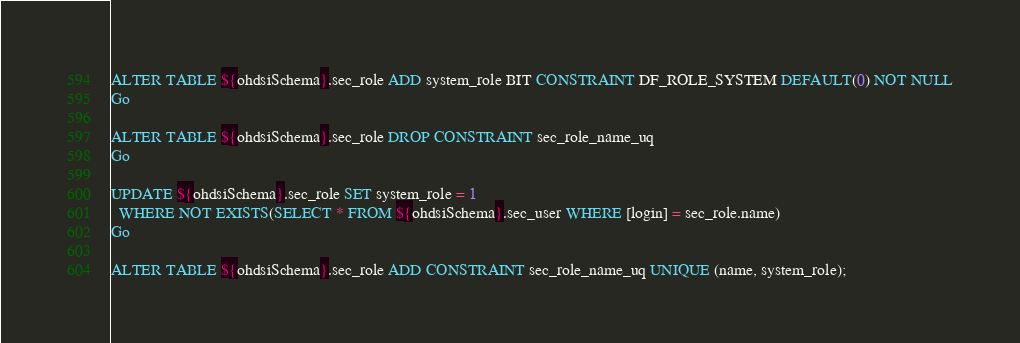Convert code to text. <code><loc_0><loc_0><loc_500><loc_500><_SQL_>ALTER TABLE ${ohdsiSchema}.sec_role ADD system_role BIT CONSTRAINT DF_ROLE_SYSTEM DEFAULT(0) NOT NULL
Go

ALTER TABLE ${ohdsiSchema}.sec_role DROP CONSTRAINT sec_role_name_uq
Go

UPDATE ${ohdsiSchema}.sec_role SET system_role = 1
  WHERE NOT EXISTS(SELECT * FROM ${ohdsiSchema}.sec_user WHERE [login] = sec_role.name)
Go

ALTER TABLE ${ohdsiSchema}.sec_role ADD CONSTRAINT sec_role_name_uq UNIQUE (name, system_role);</code> 